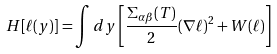<formula> <loc_0><loc_0><loc_500><loc_500>H [ \ell ( { y } ) ] = \int d { y } \left [ \frac { \Sigma _ { \alpha \beta } ( T ) } { 2 } ( \nabla \ell ) ^ { 2 } + W ( \ell ) \right ]</formula> 